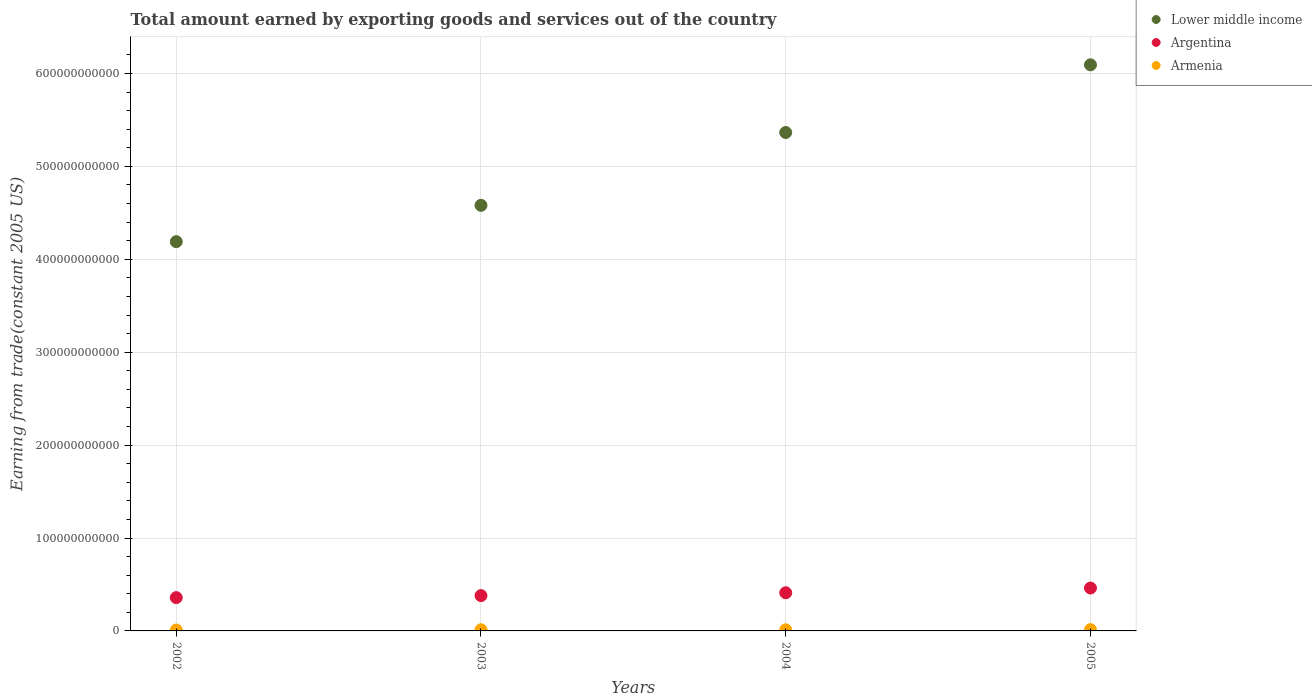How many different coloured dotlines are there?
Provide a succinct answer. 3. Is the number of dotlines equal to the number of legend labels?
Offer a terse response. Yes. What is the total amount earned by exporting goods and services in Armenia in 2002?
Your answer should be compact. 9.60e+08. Across all years, what is the maximum total amount earned by exporting goods and services in Armenia?
Give a very brief answer. 1.41e+09. Across all years, what is the minimum total amount earned by exporting goods and services in Lower middle income?
Your answer should be compact. 4.19e+11. In which year was the total amount earned by exporting goods and services in Argentina minimum?
Provide a succinct answer. 2002. What is the total total amount earned by exporting goods and services in Lower middle income in the graph?
Your answer should be compact. 2.02e+12. What is the difference between the total amount earned by exporting goods and services in Argentina in 2002 and that in 2004?
Offer a terse response. -5.23e+09. What is the difference between the total amount earned by exporting goods and services in Armenia in 2002 and the total amount earned by exporting goods and services in Lower middle income in 2003?
Give a very brief answer. -4.57e+11. What is the average total amount earned by exporting goods and services in Armenia per year?
Give a very brief answer. 1.21e+09. In the year 2003, what is the difference between the total amount earned by exporting goods and services in Lower middle income and total amount earned by exporting goods and services in Armenia?
Your response must be concise. 4.57e+11. In how many years, is the total amount earned by exporting goods and services in Lower middle income greater than 480000000000 US$?
Your answer should be compact. 2. What is the ratio of the total amount earned by exporting goods and services in Argentina in 2002 to that in 2005?
Your response must be concise. 0.78. Is the total amount earned by exporting goods and services in Argentina in 2002 less than that in 2004?
Offer a terse response. Yes. Is the difference between the total amount earned by exporting goods and services in Lower middle income in 2003 and 2004 greater than the difference between the total amount earned by exporting goods and services in Armenia in 2003 and 2004?
Give a very brief answer. No. What is the difference between the highest and the second highest total amount earned by exporting goods and services in Lower middle income?
Offer a terse response. 7.28e+1. What is the difference between the highest and the lowest total amount earned by exporting goods and services in Armenia?
Offer a terse response. 4.52e+08. Is the sum of the total amount earned by exporting goods and services in Lower middle income in 2003 and 2004 greater than the maximum total amount earned by exporting goods and services in Armenia across all years?
Ensure brevity in your answer.  Yes. How many dotlines are there?
Give a very brief answer. 3. What is the difference between two consecutive major ticks on the Y-axis?
Your response must be concise. 1.00e+11. Where does the legend appear in the graph?
Give a very brief answer. Top right. What is the title of the graph?
Keep it short and to the point. Total amount earned by exporting goods and services out of the country. Does "Korea (Republic)" appear as one of the legend labels in the graph?
Provide a short and direct response. No. What is the label or title of the Y-axis?
Your answer should be very brief. Earning from trade(constant 2005 US). What is the Earning from trade(constant 2005 US) in Lower middle income in 2002?
Provide a short and direct response. 4.19e+11. What is the Earning from trade(constant 2005 US) of Argentina in 2002?
Ensure brevity in your answer.  3.58e+1. What is the Earning from trade(constant 2005 US) of Armenia in 2002?
Keep it short and to the point. 9.60e+08. What is the Earning from trade(constant 2005 US) in Lower middle income in 2003?
Make the answer very short. 4.58e+11. What is the Earning from trade(constant 2005 US) of Argentina in 2003?
Give a very brief answer. 3.80e+1. What is the Earning from trade(constant 2005 US) of Armenia in 2003?
Offer a very short reply. 1.24e+09. What is the Earning from trade(constant 2005 US) of Lower middle income in 2004?
Your answer should be very brief. 5.36e+11. What is the Earning from trade(constant 2005 US) of Argentina in 2004?
Your response must be concise. 4.11e+1. What is the Earning from trade(constant 2005 US) in Armenia in 2004?
Your response must be concise. 1.22e+09. What is the Earning from trade(constant 2005 US) of Lower middle income in 2005?
Your answer should be compact. 6.09e+11. What is the Earning from trade(constant 2005 US) in Argentina in 2005?
Provide a succinct answer. 4.62e+1. What is the Earning from trade(constant 2005 US) of Armenia in 2005?
Give a very brief answer. 1.41e+09. Across all years, what is the maximum Earning from trade(constant 2005 US) of Lower middle income?
Give a very brief answer. 6.09e+11. Across all years, what is the maximum Earning from trade(constant 2005 US) in Argentina?
Your response must be concise. 4.62e+1. Across all years, what is the maximum Earning from trade(constant 2005 US) of Armenia?
Your response must be concise. 1.41e+09. Across all years, what is the minimum Earning from trade(constant 2005 US) in Lower middle income?
Keep it short and to the point. 4.19e+11. Across all years, what is the minimum Earning from trade(constant 2005 US) in Argentina?
Ensure brevity in your answer.  3.58e+1. Across all years, what is the minimum Earning from trade(constant 2005 US) in Armenia?
Ensure brevity in your answer.  9.60e+08. What is the total Earning from trade(constant 2005 US) in Lower middle income in the graph?
Provide a succinct answer. 2.02e+12. What is the total Earning from trade(constant 2005 US) in Argentina in the graph?
Ensure brevity in your answer.  1.61e+11. What is the total Earning from trade(constant 2005 US) of Armenia in the graph?
Keep it short and to the point. 4.83e+09. What is the difference between the Earning from trade(constant 2005 US) of Lower middle income in 2002 and that in 2003?
Your response must be concise. -3.91e+1. What is the difference between the Earning from trade(constant 2005 US) in Argentina in 2002 and that in 2003?
Provide a short and direct response. -2.15e+09. What is the difference between the Earning from trade(constant 2005 US) in Armenia in 2002 and that in 2003?
Your answer should be very brief. -2.79e+08. What is the difference between the Earning from trade(constant 2005 US) in Lower middle income in 2002 and that in 2004?
Offer a very short reply. -1.17e+11. What is the difference between the Earning from trade(constant 2005 US) in Argentina in 2002 and that in 2004?
Keep it short and to the point. -5.23e+09. What is the difference between the Earning from trade(constant 2005 US) in Armenia in 2002 and that in 2004?
Offer a very short reply. -2.58e+08. What is the difference between the Earning from trade(constant 2005 US) of Lower middle income in 2002 and that in 2005?
Keep it short and to the point. -1.90e+11. What is the difference between the Earning from trade(constant 2005 US) in Argentina in 2002 and that in 2005?
Ensure brevity in your answer.  -1.03e+1. What is the difference between the Earning from trade(constant 2005 US) of Armenia in 2002 and that in 2005?
Offer a terse response. -4.52e+08. What is the difference between the Earning from trade(constant 2005 US) in Lower middle income in 2003 and that in 2004?
Offer a very short reply. -7.84e+1. What is the difference between the Earning from trade(constant 2005 US) in Argentina in 2003 and that in 2004?
Offer a very short reply. -3.08e+09. What is the difference between the Earning from trade(constant 2005 US) in Armenia in 2003 and that in 2004?
Make the answer very short. 2.14e+07. What is the difference between the Earning from trade(constant 2005 US) of Lower middle income in 2003 and that in 2005?
Make the answer very short. -1.51e+11. What is the difference between the Earning from trade(constant 2005 US) of Argentina in 2003 and that in 2005?
Give a very brief answer. -8.17e+09. What is the difference between the Earning from trade(constant 2005 US) in Armenia in 2003 and that in 2005?
Give a very brief answer. -1.73e+08. What is the difference between the Earning from trade(constant 2005 US) of Lower middle income in 2004 and that in 2005?
Your answer should be very brief. -7.28e+1. What is the difference between the Earning from trade(constant 2005 US) of Argentina in 2004 and that in 2005?
Provide a succinct answer. -5.08e+09. What is the difference between the Earning from trade(constant 2005 US) of Armenia in 2004 and that in 2005?
Keep it short and to the point. -1.94e+08. What is the difference between the Earning from trade(constant 2005 US) in Lower middle income in 2002 and the Earning from trade(constant 2005 US) in Argentina in 2003?
Provide a short and direct response. 3.81e+11. What is the difference between the Earning from trade(constant 2005 US) in Lower middle income in 2002 and the Earning from trade(constant 2005 US) in Armenia in 2003?
Provide a succinct answer. 4.18e+11. What is the difference between the Earning from trade(constant 2005 US) of Argentina in 2002 and the Earning from trade(constant 2005 US) of Armenia in 2003?
Offer a terse response. 3.46e+1. What is the difference between the Earning from trade(constant 2005 US) of Lower middle income in 2002 and the Earning from trade(constant 2005 US) of Argentina in 2004?
Offer a terse response. 3.78e+11. What is the difference between the Earning from trade(constant 2005 US) in Lower middle income in 2002 and the Earning from trade(constant 2005 US) in Armenia in 2004?
Keep it short and to the point. 4.18e+11. What is the difference between the Earning from trade(constant 2005 US) of Argentina in 2002 and the Earning from trade(constant 2005 US) of Armenia in 2004?
Provide a succinct answer. 3.46e+1. What is the difference between the Earning from trade(constant 2005 US) of Lower middle income in 2002 and the Earning from trade(constant 2005 US) of Argentina in 2005?
Provide a succinct answer. 3.73e+11. What is the difference between the Earning from trade(constant 2005 US) of Lower middle income in 2002 and the Earning from trade(constant 2005 US) of Armenia in 2005?
Give a very brief answer. 4.18e+11. What is the difference between the Earning from trade(constant 2005 US) of Argentina in 2002 and the Earning from trade(constant 2005 US) of Armenia in 2005?
Provide a short and direct response. 3.44e+1. What is the difference between the Earning from trade(constant 2005 US) of Lower middle income in 2003 and the Earning from trade(constant 2005 US) of Argentina in 2004?
Your answer should be compact. 4.17e+11. What is the difference between the Earning from trade(constant 2005 US) in Lower middle income in 2003 and the Earning from trade(constant 2005 US) in Armenia in 2004?
Provide a short and direct response. 4.57e+11. What is the difference between the Earning from trade(constant 2005 US) of Argentina in 2003 and the Earning from trade(constant 2005 US) of Armenia in 2004?
Offer a very short reply. 3.68e+1. What is the difference between the Earning from trade(constant 2005 US) in Lower middle income in 2003 and the Earning from trade(constant 2005 US) in Argentina in 2005?
Provide a short and direct response. 4.12e+11. What is the difference between the Earning from trade(constant 2005 US) in Lower middle income in 2003 and the Earning from trade(constant 2005 US) in Armenia in 2005?
Give a very brief answer. 4.57e+11. What is the difference between the Earning from trade(constant 2005 US) in Argentina in 2003 and the Earning from trade(constant 2005 US) in Armenia in 2005?
Provide a succinct answer. 3.66e+1. What is the difference between the Earning from trade(constant 2005 US) in Lower middle income in 2004 and the Earning from trade(constant 2005 US) in Argentina in 2005?
Your response must be concise. 4.90e+11. What is the difference between the Earning from trade(constant 2005 US) of Lower middle income in 2004 and the Earning from trade(constant 2005 US) of Armenia in 2005?
Your answer should be very brief. 5.35e+11. What is the difference between the Earning from trade(constant 2005 US) in Argentina in 2004 and the Earning from trade(constant 2005 US) in Armenia in 2005?
Your answer should be compact. 3.97e+1. What is the average Earning from trade(constant 2005 US) of Lower middle income per year?
Ensure brevity in your answer.  5.06e+11. What is the average Earning from trade(constant 2005 US) in Argentina per year?
Your response must be concise. 4.03e+1. What is the average Earning from trade(constant 2005 US) in Armenia per year?
Your answer should be compact. 1.21e+09. In the year 2002, what is the difference between the Earning from trade(constant 2005 US) in Lower middle income and Earning from trade(constant 2005 US) in Argentina?
Provide a short and direct response. 3.83e+11. In the year 2002, what is the difference between the Earning from trade(constant 2005 US) of Lower middle income and Earning from trade(constant 2005 US) of Armenia?
Make the answer very short. 4.18e+11. In the year 2002, what is the difference between the Earning from trade(constant 2005 US) of Argentina and Earning from trade(constant 2005 US) of Armenia?
Your answer should be compact. 3.49e+1. In the year 2003, what is the difference between the Earning from trade(constant 2005 US) of Lower middle income and Earning from trade(constant 2005 US) of Argentina?
Offer a very short reply. 4.20e+11. In the year 2003, what is the difference between the Earning from trade(constant 2005 US) of Lower middle income and Earning from trade(constant 2005 US) of Armenia?
Offer a very short reply. 4.57e+11. In the year 2003, what is the difference between the Earning from trade(constant 2005 US) of Argentina and Earning from trade(constant 2005 US) of Armenia?
Keep it short and to the point. 3.68e+1. In the year 2004, what is the difference between the Earning from trade(constant 2005 US) in Lower middle income and Earning from trade(constant 2005 US) in Argentina?
Offer a terse response. 4.95e+11. In the year 2004, what is the difference between the Earning from trade(constant 2005 US) in Lower middle income and Earning from trade(constant 2005 US) in Armenia?
Make the answer very short. 5.35e+11. In the year 2004, what is the difference between the Earning from trade(constant 2005 US) of Argentina and Earning from trade(constant 2005 US) of Armenia?
Your response must be concise. 3.99e+1. In the year 2005, what is the difference between the Earning from trade(constant 2005 US) in Lower middle income and Earning from trade(constant 2005 US) in Argentina?
Provide a succinct answer. 5.63e+11. In the year 2005, what is the difference between the Earning from trade(constant 2005 US) in Lower middle income and Earning from trade(constant 2005 US) in Armenia?
Ensure brevity in your answer.  6.08e+11. In the year 2005, what is the difference between the Earning from trade(constant 2005 US) of Argentina and Earning from trade(constant 2005 US) of Armenia?
Make the answer very short. 4.47e+1. What is the ratio of the Earning from trade(constant 2005 US) in Lower middle income in 2002 to that in 2003?
Your answer should be very brief. 0.91. What is the ratio of the Earning from trade(constant 2005 US) in Argentina in 2002 to that in 2003?
Your answer should be compact. 0.94. What is the ratio of the Earning from trade(constant 2005 US) of Armenia in 2002 to that in 2003?
Your response must be concise. 0.77. What is the ratio of the Earning from trade(constant 2005 US) in Lower middle income in 2002 to that in 2004?
Provide a short and direct response. 0.78. What is the ratio of the Earning from trade(constant 2005 US) in Argentina in 2002 to that in 2004?
Ensure brevity in your answer.  0.87. What is the ratio of the Earning from trade(constant 2005 US) of Armenia in 2002 to that in 2004?
Your answer should be compact. 0.79. What is the ratio of the Earning from trade(constant 2005 US) of Lower middle income in 2002 to that in 2005?
Offer a terse response. 0.69. What is the ratio of the Earning from trade(constant 2005 US) in Argentina in 2002 to that in 2005?
Your answer should be very brief. 0.78. What is the ratio of the Earning from trade(constant 2005 US) of Armenia in 2002 to that in 2005?
Keep it short and to the point. 0.68. What is the ratio of the Earning from trade(constant 2005 US) in Lower middle income in 2003 to that in 2004?
Give a very brief answer. 0.85. What is the ratio of the Earning from trade(constant 2005 US) in Argentina in 2003 to that in 2004?
Ensure brevity in your answer.  0.92. What is the ratio of the Earning from trade(constant 2005 US) of Armenia in 2003 to that in 2004?
Your response must be concise. 1.02. What is the ratio of the Earning from trade(constant 2005 US) in Lower middle income in 2003 to that in 2005?
Offer a very short reply. 0.75. What is the ratio of the Earning from trade(constant 2005 US) in Argentina in 2003 to that in 2005?
Keep it short and to the point. 0.82. What is the ratio of the Earning from trade(constant 2005 US) in Armenia in 2003 to that in 2005?
Your response must be concise. 0.88. What is the ratio of the Earning from trade(constant 2005 US) in Lower middle income in 2004 to that in 2005?
Ensure brevity in your answer.  0.88. What is the ratio of the Earning from trade(constant 2005 US) of Argentina in 2004 to that in 2005?
Provide a short and direct response. 0.89. What is the ratio of the Earning from trade(constant 2005 US) in Armenia in 2004 to that in 2005?
Ensure brevity in your answer.  0.86. What is the difference between the highest and the second highest Earning from trade(constant 2005 US) in Lower middle income?
Your response must be concise. 7.28e+1. What is the difference between the highest and the second highest Earning from trade(constant 2005 US) of Argentina?
Your response must be concise. 5.08e+09. What is the difference between the highest and the second highest Earning from trade(constant 2005 US) of Armenia?
Your answer should be very brief. 1.73e+08. What is the difference between the highest and the lowest Earning from trade(constant 2005 US) in Lower middle income?
Your answer should be very brief. 1.90e+11. What is the difference between the highest and the lowest Earning from trade(constant 2005 US) of Argentina?
Make the answer very short. 1.03e+1. What is the difference between the highest and the lowest Earning from trade(constant 2005 US) in Armenia?
Provide a succinct answer. 4.52e+08. 